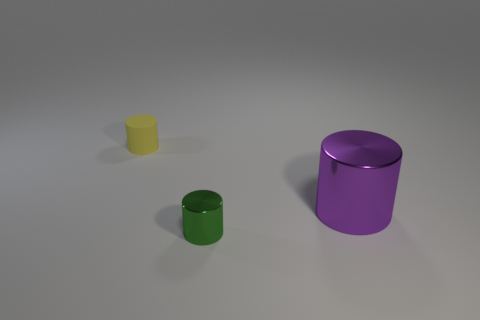Subtract all small cylinders. How many cylinders are left? 1 Subtract all purple cylinders. How many cylinders are left? 2 Add 3 small cylinders. How many objects exist? 6 Subtract 0 blue cylinders. How many objects are left? 3 Subtract 2 cylinders. How many cylinders are left? 1 Subtract all red cylinders. Subtract all red spheres. How many cylinders are left? 3 Subtract all brown balls. How many purple cylinders are left? 1 Subtract all small green metallic objects. Subtract all tiny cylinders. How many objects are left? 0 Add 2 big purple things. How many big purple things are left? 3 Add 1 tiny objects. How many tiny objects exist? 3 